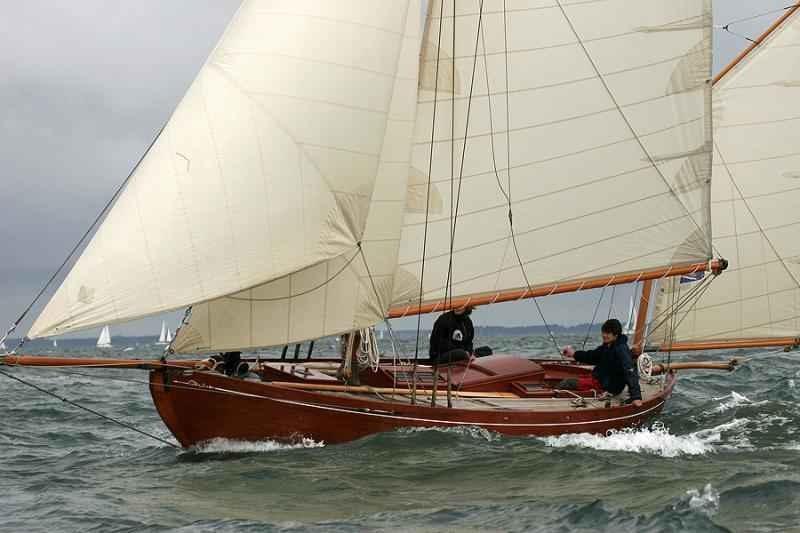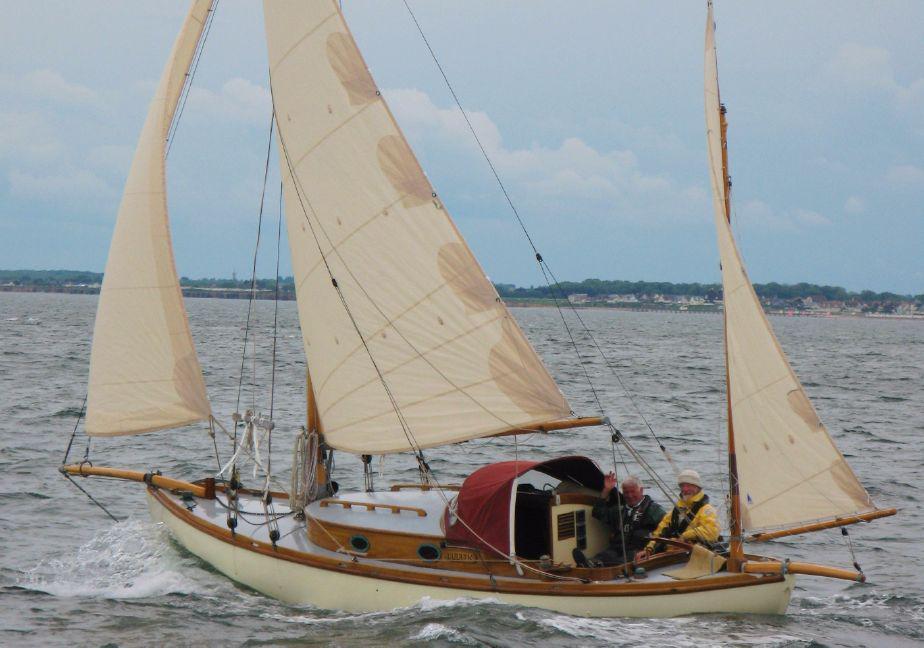The first image is the image on the left, the second image is the image on the right. For the images shown, is this caption "There are 5 raised sails in the image pair" true? Answer yes or no. No. The first image is the image on the left, the second image is the image on the right. Evaluate the accuracy of this statement regarding the images: "There are exactly five sails.". Is it true? Answer yes or no. No. 